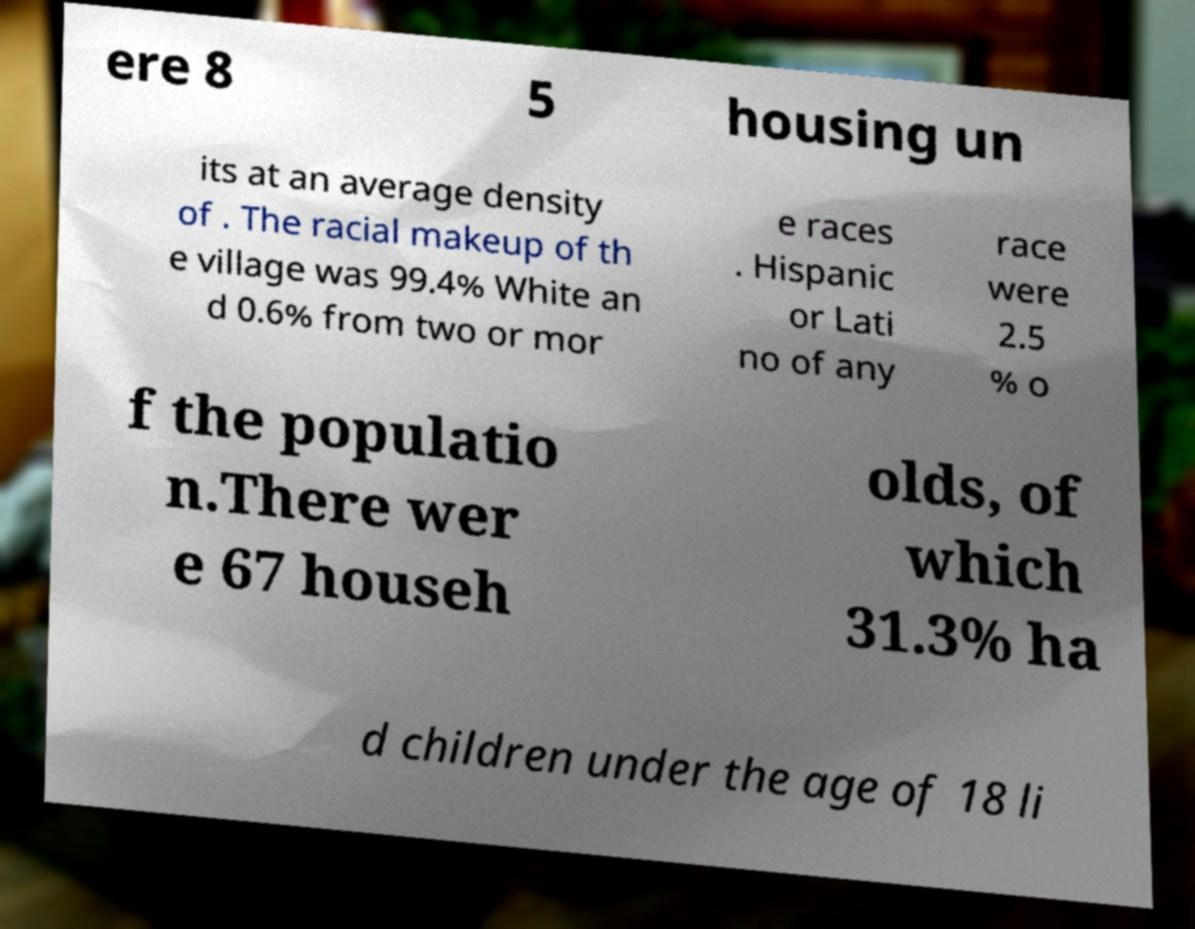Please read and relay the text visible in this image. What does it say? ere 8 5 housing un its at an average density of . The racial makeup of th e village was 99.4% White an d 0.6% from two or mor e races . Hispanic or Lati no of any race were 2.5 % o f the populatio n.There wer e 67 househ olds, of which 31.3% ha d children under the age of 18 li 